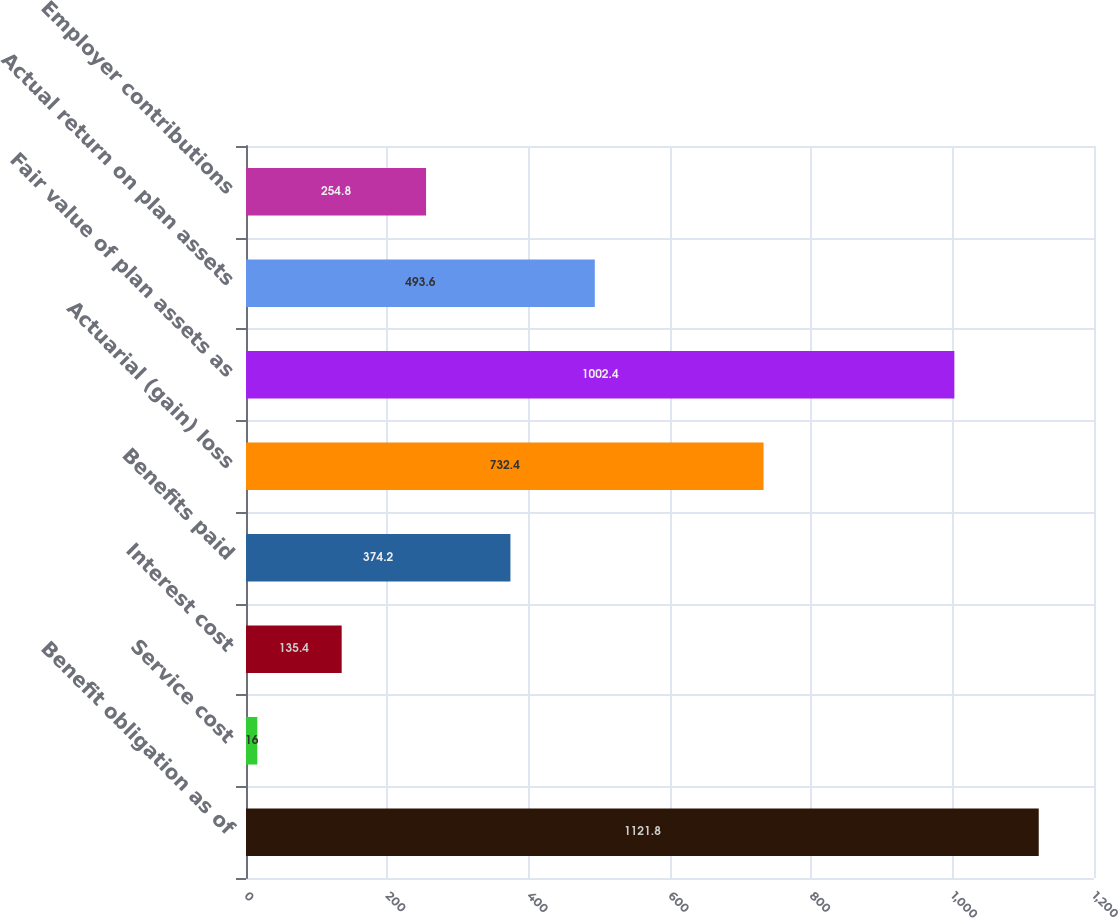<chart> <loc_0><loc_0><loc_500><loc_500><bar_chart><fcel>Benefit obligation as of<fcel>Service cost<fcel>Interest cost<fcel>Benefits paid<fcel>Actuarial (gain) loss<fcel>Fair value of plan assets as<fcel>Actual return on plan assets<fcel>Employer contributions<nl><fcel>1121.8<fcel>16<fcel>135.4<fcel>374.2<fcel>732.4<fcel>1002.4<fcel>493.6<fcel>254.8<nl></chart> 